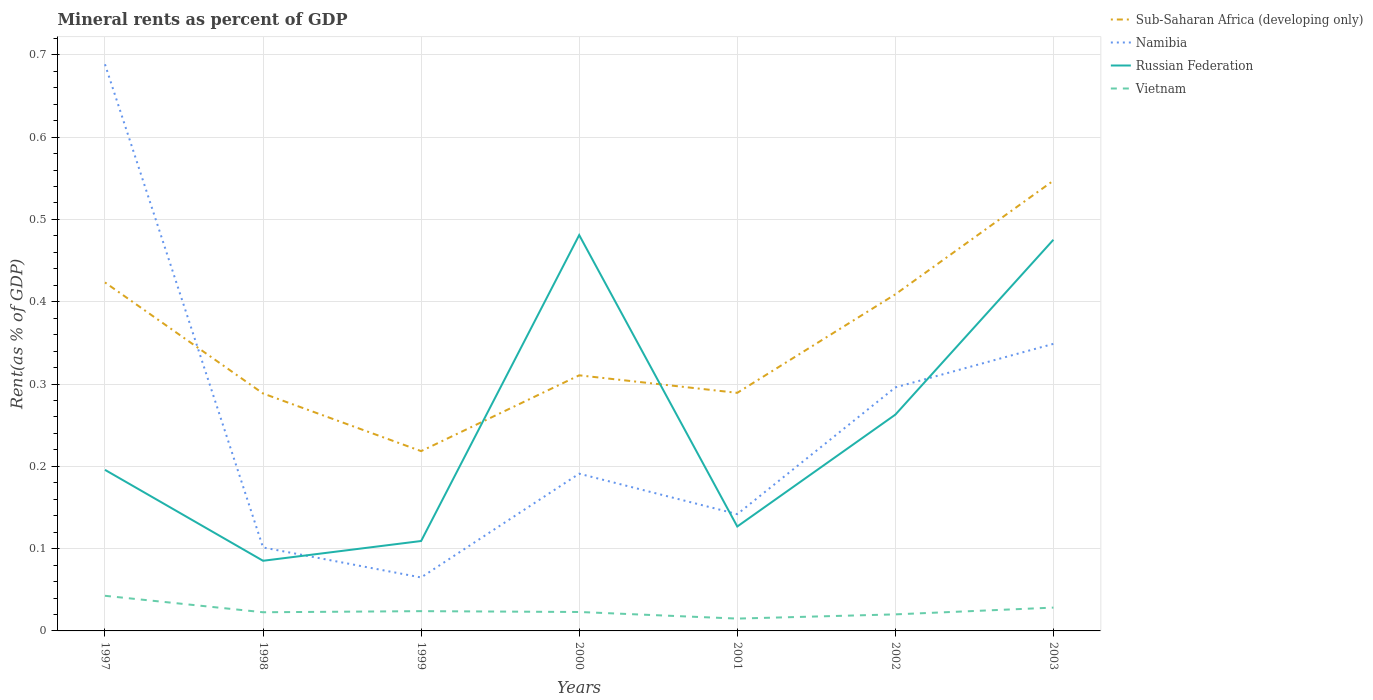How many different coloured lines are there?
Your answer should be compact. 4. Across all years, what is the maximum mineral rent in Sub-Saharan Africa (developing only)?
Ensure brevity in your answer.  0.22. What is the total mineral rent in Vietnam in the graph?
Provide a succinct answer. -0. What is the difference between the highest and the second highest mineral rent in Russian Federation?
Provide a short and direct response. 0.4. What is the difference between the highest and the lowest mineral rent in Vietnam?
Your answer should be compact. 2. How many lines are there?
Make the answer very short. 4. How many years are there in the graph?
Your response must be concise. 7. Does the graph contain any zero values?
Make the answer very short. No. How many legend labels are there?
Your answer should be very brief. 4. What is the title of the graph?
Provide a succinct answer. Mineral rents as percent of GDP. What is the label or title of the X-axis?
Your response must be concise. Years. What is the label or title of the Y-axis?
Offer a terse response. Rent(as % of GDP). What is the Rent(as % of GDP) of Sub-Saharan Africa (developing only) in 1997?
Offer a very short reply. 0.42. What is the Rent(as % of GDP) in Namibia in 1997?
Your answer should be very brief. 0.69. What is the Rent(as % of GDP) of Russian Federation in 1997?
Provide a short and direct response. 0.2. What is the Rent(as % of GDP) in Vietnam in 1997?
Your answer should be very brief. 0.04. What is the Rent(as % of GDP) in Sub-Saharan Africa (developing only) in 1998?
Your response must be concise. 0.29. What is the Rent(as % of GDP) of Namibia in 1998?
Give a very brief answer. 0.1. What is the Rent(as % of GDP) of Russian Federation in 1998?
Make the answer very short. 0.09. What is the Rent(as % of GDP) of Vietnam in 1998?
Ensure brevity in your answer.  0.02. What is the Rent(as % of GDP) of Sub-Saharan Africa (developing only) in 1999?
Ensure brevity in your answer.  0.22. What is the Rent(as % of GDP) of Namibia in 1999?
Offer a very short reply. 0.06. What is the Rent(as % of GDP) in Russian Federation in 1999?
Keep it short and to the point. 0.11. What is the Rent(as % of GDP) of Vietnam in 1999?
Provide a short and direct response. 0.02. What is the Rent(as % of GDP) in Sub-Saharan Africa (developing only) in 2000?
Your answer should be very brief. 0.31. What is the Rent(as % of GDP) in Namibia in 2000?
Your response must be concise. 0.19. What is the Rent(as % of GDP) of Russian Federation in 2000?
Your answer should be compact. 0.48. What is the Rent(as % of GDP) in Vietnam in 2000?
Your answer should be very brief. 0.02. What is the Rent(as % of GDP) of Sub-Saharan Africa (developing only) in 2001?
Ensure brevity in your answer.  0.29. What is the Rent(as % of GDP) in Namibia in 2001?
Offer a terse response. 0.14. What is the Rent(as % of GDP) of Russian Federation in 2001?
Provide a succinct answer. 0.13. What is the Rent(as % of GDP) in Vietnam in 2001?
Your answer should be compact. 0.01. What is the Rent(as % of GDP) in Sub-Saharan Africa (developing only) in 2002?
Ensure brevity in your answer.  0.41. What is the Rent(as % of GDP) of Namibia in 2002?
Provide a short and direct response. 0.3. What is the Rent(as % of GDP) in Russian Federation in 2002?
Ensure brevity in your answer.  0.26. What is the Rent(as % of GDP) in Vietnam in 2002?
Your answer should be compact. 0.02. What is the Rent(as % of GDP) in Sub-Saharan Africa (developing only) in 2003?
Your answer should be compact. 0.55. What is the Rent(as % of GDP) in Namibia in 2003?
Offer a terse response. 0.35. What is the Rent(as % of GDP) in Russian Federation in 2003?
Offer a terse response. 0.48. What is the Rent(as % of GDP) of Vietnam in 2003?
Your response must be concise. 0.03. Across all years, what is the maximum Rent(as % of GDP) of Sub-Saharan Africa (developing only)?
Provide a short and direct response. 0.55. Across all years, what is the maximum Rent(as % of GDP) in Namibia?
Provide a short and direct response. 0.69. Across all years, what is the maximum Rent(as % of GDP) of Russian Federation?
Offer a very short reply. 0.48. Across all years, what is the maximum Rent(as % of GDP) of Vietnam?
Keep it short and to the point. 0.04. Across all years, what is the minimum Rent(as % of GDP) in Sub-Saharan Africa (developing only)?
Make the answer very short. 0.22. Across all years, what is the minimum Rent(as % of GDP) of Namibia?
Your answer should be very brief. 0.06. Across all years, what is the minimum Rent(as % of GDP) in Russian Federation?
Offer a very short reply. 0.09. Across all years, what is the minimum Rent(as % of GDP) in Vietnam?
Provide a succinct answer. 0.01. What is the total Rent(as % of GDP) in Sub-Saharan Africa (developing only) in the graph?
Ensure brevity in your answer.  2.49. What is the total Rent(as % of GDP) in Namibia in the graph?
Provide a succinct answer. 1.83. What is the total Rent(as % of GDP) of Russian Federation in the graph?
Your answer should be very brief. 1.74. What is the total Rent(as % of GDP) in Vietnam in the graph?
Provide a succinct answer. 0.18. What is the difference between the Rent(as % of GDP) of Sub-Saharan Africa (developing only) in 1997 and that in 1998?
Provide a succinct answer. 0.13. What is the difference between the Rent(as % of GDP) of Namibia in 1997 and that in 1998?
Ensure brevity in your answer.  0.59. What is the difference between the Rent(as % of GDP) in Russian Federation in 1997 and that in 1998?
Offer a very short reply. 0.11. What is the difference between the Rent(as % of GDP) in Sub-Saharan Africa (developing only) in 1997 and that in 1999?
Give a very brief answer. 0.2. What is the difference between the Rent(as % of GDP) in Namibia in 1997 and that in 1999?
Offer a terse response. 0.62. What is the difference between the Rent(as % of GDP) in Russian Federation in 1997 and that in 1999?
Your response must be concise. 0.09. What is the difference between the Rent(as % of GDP) in Vietnam in 1997 and that in 1999?
Provide a short and direct response. 0.02. What is the difference between the Rent(as % of GDP) in Sub-Saharan Africa (developing only) in 1997 and that in 2000?
Give a very brief answer. 0.11. What is the difference between the Rent(as % of GDP) in Namibia in 1997 and that in 2000?
Offer a very short reply. 0.5. What is the difference between the Rent(as % of GDP) in Russian Federation in 1997 and that in 2000?
Your answer should be compact. -0.29. What is the difference between the Rent(as % of GDP) of Vietnam in 1997 and that in 2000?
Your answer should be very brief. 0.02. What is the difference between the Rent(as % of GDP) in Sub-Saharan Africa (developing only) in 1997 and that in 2001?
Your answer should be very brief. 0.13. What is the difference between the Rent(as % of GDP) of Namibia in 1997 and that in 2001?
Give a very brief answer. 0.55. What is the difference between the Rent(as % of GDP) of Russian Federation in 1997 and that in 2001?
Offer a very short reply. 0.07. What is the difference between the Rent(as % of GDP) of Vietnam in 1997 and that in 2001?
Keep it short and to the point. 0.03. What is the difference between the Rent(as % of GDP) in Sub-Saharan Africa (developing only) in 1997 and that in 2002?
Your answer should be compact. 0.01. What is the difference between the Rent(as % of GDP) of Namibia in 1997 and that in 2002?
Give a very brief answer. 0.39. What is the difference between the Rent(as % of GDP) of Russian Federation in 1997 and that in 2002?
Offer a terse response. -0.07. What is the difference between the Rent(as % of GDP) in Vietnam in 1997 and that in 2002?
Offer a terse response. 0.02. What is the difference between the Rent(as % of GDP) of Sub-Saharan Africa (developing only) in 1997 and that in 2003?
Keep it short and to the point. -0.12. What is the difference between the Rent(as % of GDP) in Namibia in 1997 and that in 2003?
Provide a short and direct response. 0.34. What is the difference between the Rent(as % of GDP) in Russian Federation in 1997 and that in 2003?
Ensure brevity in your answer.  -0.28. What is the difference between the Rent(as % of GDP) in Vietnam in 1997 and that in 2003?
Offer a terse response. 0.01. What is the difference between the Rent(as % of GDP) of Sub-Saharan Africa (developing only) in 1998 and that in 1999?
Make the answer very short. 0.07. What is the difference between the Rent(as % of GDP) of Namibia in 1998 and that in 1999?
Offer a terse response. 0.04. What is the difference between the Rent(as % of GDP) of Russian Federation in 1998 and that in 1999?
Your response must be concise. -0.02. What is the difference between the Rent(as % of GDP) in Vietnam in 1998 and that in 1999?
Your response must be concise. -0. What is the difference between the Rent(as % of GDP) in Sub-Saharan Africa (developing only) in 1998 and that in 2000?
Offer a very short reply. -0.02. What is the difference between the Rent(as % of GDP) in Namibia in 1998 and that in 2000?
Keep it short and to the point. -0.09. What is the difference between the Rent(as % of GDP) of Russian Federation in 1998 and that in 2000?
Your response must be concise. -0.4. What is the difference between the Rent(as % of GDP) in Vietnam in 1998 and that in 2000?
Provide a short and direct response. -0. What is the difference between the Rent(as % of GDP) in Sub-Saharan Africa (developing only) in 1998 and that in 2001?
Offer a very short reply. -0. What is the difference between the Rent(as % of GDP) of Namibia in 1998 and that in 2001?
Make the answer very short. -0.04. What is the difference between the Rent(as % of GDP) in Russian Federation in 1998 and that in 2001?
Provide a succinct answer. -0.04. What is the difference between the Rent(as % of GDP) in Vietnam in 1998 and that in 2001?
Provide a short and direct response. 0.01. What is the difference between the Rent(as % of GDP) of Sub-Saharan Africa (developing only) in 1998 and that in 2002?
Offer a terse response. -0.12. What is the difference between the Rent(as % of GDP) of Namibia in 1998 and that in 2002?
Provide a succinct answer. -0.19. What is the difference between the Rent(as % of GDP) in Russian Federation in 1998 and that in 2002?
Ensure brevity in your answer.  -0.18. What is the difference between the Rent(as % of GDP) in Vietnam in 1998 and that in 2002?
Offer a terse response. 0. What is the difference between the Rent(as % of GDP) in Sub-Saharan Africa (developing only) in 1998 and that in 2003?
Make the answer very short. -0.26. What is the difference between the Rent(as % of GDP) in Namibia in 1998 and that in 2003?
Ensure brevity in your answer.  -0.25. What is the difference between the Rent(as % of GDP) in Russian Federation in 1998 and that in 2003?
Offer a terse response. -0.39. What is the difference between the Rent(as % of GDP) of Vietnam in 1998 and that in 2003?
Give a very brief answer. -0.01. What is the difference between the Rent(as % of GDP) in Sub-Saharan Africa (developing only) in 1999 and that in 2000?
Keep it short and to the point. -0.09. What is the difference between the Rent(as % of GDP) in Namibia in 1999 and that in 2000?
Your answer should be compact. -0.13. What is the difference between the Rent(as % of GDP) in Russian Federation in 1999 and that in 2000?
Make the answer very short. -0.37. What is the difference between the Rent(as % of GDP) of Vietnam in 1999 and that in 2000?
Keep it short and to the point. 0. What is the difference between the Rent(as % of GDP) in Sub-Saharan Africa (developing only) in 1999 and that in 2001?
Your response must be concise. -0.07. What is the difference between the Rent(as % of GDP) of Namibia in 1999 and that in 2001?
Give a very brief answer. -0.08. What is the difference between the Rent(as % of GDP) in Russian Federation in 1999 and that in 2001?
Keep it short and to the point. -0.02. What is the difference between the Rent(as % of GDP) in Vietnam in 1999 and that in 2001?
Ensure brevity in your answer.  0.01. What is the difference between the Rent(as % of GDP) in Sub-Saharan Africa (developing only) in 1999 and that in 2002?
Your response must be concise. -0.19. What is the difference between the Rent(as % of GDP) in Namibia in 1999 and that in 2002?
Your answer should be very brief. -0.23. What is the difference between the Rent(as % of GDP) in Russian Federation in 1999 and that in 2002?
Your answer should be very brief. -0.15. What is the difference between the Rent(as % of GDP) in Vietnam in 1999 and that in 2002?
Offer a very short reply. 0. What is the difference between the Rent(as % of GDP) of Sub-Saharan Africa (developing only) in 1999 and that in 2003?
Your answer should be compact. -0.33. What is the difference between the Rent(as % of GDP) in Namibia in 1999 and that in 2003?
Provide a short and direct response. -0.28. What is the difference between the Rent(as % of GDP) in Russian Federation in 1999 and that in 2003?
Make the answer very short. -0.37. What is the difference between the Rent(as % of GDP) in Vietnam in 1999 and that in 2003?
Ensure brevity in your answer.  -0. What is the difference between the Rent(as % of GDP) of Sub-Saharan Africa (developing only) in 2000 and that in 2001?
Your response must be concise. 0.02. What is the difference between the Rent(as % of GDP) in Namibia in 2000 and that in 2001?
Your response must be concise. 0.05. What is the difference between the Rent(as % of GDP) of Russian Federation in 2000 and that in 2001?
Provide a succinct answer. 0.35. What is the difference between the Rent(as % of GDP) of Vietnam in 2000 and that in 2001?
Offer a very short reply. 0.01. What is the difference between the Rent(as % of GDP) in Sub-Saharan Africa (developing only) in 2000 and that in 2002?
Your answer should be very brief. -0.1. What is the difference between the Rent(as % of GDP) in Namibia in 2000 and that in 2002?
Give a very brief answer. -0.1. What is the difference between the Rent(as % of GDP) in Russian Federation in 2000 and that in 2002?
Provide a short and direct response. 0.22. What is the difference between the Rent(as % of GDP) of Vietnam in 2000 and that in 2002?
Your response must be concise. 0. What is the difference between the Rent(as % of GDP) of Sub-Saharan Africa (developing only) in 2000 and that in 2003?
Provide a succinct answer. -0.24. What is the difference between the Rent(as % of GDP) of Namibia in 2000 and that in 2003?
Provide a succinct answer. -0.16. What is the difference between the Rent(as % of GDP) in Russian Federation in 2000 and that in 2003?
Give a very brief answer. 0.01. What is the difference between the Rent(as % of GDP) of Vietnam in 2000 and that in 2003?
Keep it short and to the point. -0.01. What is the difference between the Rent(as % of GDP) of Sub-Saharan Africa (developing only) in 2001 and that in 2002?
Offer a very short reply. -0.12. What is the difference between the Rent(as % of GDP) in Namibia in 2001 and that in 2002?
Your answer should be very brief. -0.15. What is the difference between the Rent(as % of GDP) in Russian Federation in 2001 and that in 2002?
Your answer should be compact. -0.14. What is the difference between the Rent(as % of GDP) of Vietnam in 2001 and that in 2002?
Provide a short and direct response. -0.01. What is the difference between the Rent(as % of GDP) in Sub-Saharan Africa (developing only) in 2001 and that in 2003?
Offer a terse response. -0.26. What is the difference between the Rent(as % of GDP) of Namibia in 2001 and that in 2003?
Keep it short and to the point. -0.21. What is the difference between the Rent(as % of GDP) in Russian Federation in 2001 and that in 2003?
Your response must be concise. -0.35. What is the difference between the Rent(as % of GDP) in Vietnam in 2001 and that in 2003?
Give a very brief answer. -0.01. What is the difference between the Rent(as % of GDP) in Sub-Saharan Africa (developing only) in 2002 and that in 2003?
Provide a succinct answer. -0.14. What is the difference between the Rent(as % of GDP) in Namibia in 2002 and that in 2003?
Your answer should be very brief. -0.05. What is the difference between the Rent(as % of GDP) in Russian Federation in 2002 and that in 2003?
Your response must be concise. -0.21. What is the difference between the Rent(as % of GDP) of Vietnam in 2002 and that in 2003?
Keep it short and to the point. -0.01. What is the difference between the Rent(as % of GDP) in Sub-Saharan Africa (developing only) in 1997 and the Rent(as % of GDP) in Namibia in 1998?
Offer a very short reply. 0.32. What is the difference between the Rent(as % of GDP) of Sub-Saharan Africa (developing only) in 1997 and the Rent(as % of GDP) of Russian Federation in 1998?
Give a very brief answer. 0.34. What is the difference between the Rent(as % of GDP) in Sub-Saharan Africa (developing only) in 1997 and the Rent(as % of GDP) in Vietnam in 1998?
Keep it short and to the point. 0.4. What is the difference between the Rent(as % of GDP) of Namibia in 1997 and the Rent(as % of GDP) of Russian Federation in 1998?
Give a very brief answer. 0.6. What is the difference between the Rent(as % of GDP) of Namibia in 1997 and the Rent(as % of GDP) of Vietnam in 1998?
Provide a succinct answer. 0.67. What is the difference between the Rent(as % of GDP) in Russian Federation in 1997 and the Rent(as % of GDP) in Vietnam in 1998?
Your answer should be very brief. 0.17. What is the difference between the Rent(as % of GDP) of Sub-Saharan Africa (developing only) in 1997 and the Rent(as % of GDP) of Namibia in 1999?
Your answer should be very brief. 0.36. What is the difference between the Rent(as % of GDP) of Sub-Saharan Africa (developing only) in 1997 and the Rent(as % of GDP) of Russian Federation in 1999?
Your answer should be compact. 0.31. What is the difference between the Rent(as % of GDP) of Sub-Saharan Africa (developing only) in 1997 and the Rent(as % of GDP) of Vietnam in 1999?
Your response must be concise. 0.4. What is the difference between the Rent(as % of GDP) in Namibia in 1997 and the Rent(as % of GDP) in Russian Federation in 1999?
Your answer should be very brief. 0.58. What is the difference between the Rent(as % of GDP) of Namibia in 1997 and the Rent(as % of GDP) of Vietnam in 1999?
Offer a very short reply. 0.66. What is the difference between the Rent(as % of GDP) of Russian Federation in 1997 and the Rent(as % of GDP) of Vietnam in 1999?
Provide a short and direct response. 0.17. What is the difference between the Rent(as % of GDP) of Sub-Saharan Africa (developing only) in 1997 and the Rent(as % of GDP) of Namibia in 2000?
Your answer should be compact. 0.23. What is the difference between the Rent(as % of GDP) of Sub-Saharan Africa (developing only) in 1997 and the Rent(as % of GDP) of Russian Federation in 2000?
Provide a succinct answer. -0.06. What is the difference between the Rent(as % of GDP) of Sub-Saharan Africa (developing only) in 1997 and the Rent(as % of GDP) of Vietnam in 2000?
Provide a succinct answer. 0.4. What is the difference between the Rent(as % of GDP) of Namibia in 1997 and the Rent(as % of GDP) of Russian Federation in 2000?
Keep it short and to the point. 0.21. What is the difference between the Rent(as % of GDP) in Namibia in 1997 and the Rent(as % of GDP) in Vietnam in 2000?
Your response must be concise. 0.67. What is the difference between the Rent(as % of GDP) in Russian Federation in 1997 and the Rent(as % of GDP) in Vietnam in 2000?
Your answer should be very brief. 0.17. What is the difference between the Rent(as % of GDP) of Sub-Saharan Africa (developing only) in 1997 and the Rent(as % of GDP) of Namibia in 2001?
Your response must be concise. 0.28. What is the difference between the Rent(as % of GDP) in Sub-Saharan Africa (developing only) in 1997 and the Rent(as % of GDP) in Russian Federation in 2001?
Your answer should be compact. 0.3. What is the difference between the Rent(as % of GDP) in Sub-Saharan Africa (developing only) in 1997 and the Rent(as % of GDP) in Vietnam in 2001?
Make the answer very short. 0.41. What is the difference between the Rent(as % of GDP) of Namibia in 1997 and the Rent(as % of GDP) of Russian Federation in 2001?
Offer a terse response. 0.56. What is the difference between the Rent(as % of GDP) in Namibia in 1997 and the Rent(as % of GDP) in Vietnam in 2001?
Offer a very short reply. 0.67. What is the difference between the Rent(as % of GDP) of Russian Federation in 1997 and the Rent(as % of GDP) of Vietnam in 2001?
Make the answer very short. 0.18. What is the difference between the Rent(as % of GDP) in Sub-Saharan Africa (developing only) in 1997 and the Rent(as % of GDP) in Namibia in 2002?
Your answer should be very brief. 0.13. What is the difference between the Rent(as % of GDP) in Sub-Saharan Africa (developing only) in 1997 and the Rent(as % of GDP) in Russian Federation in 2002?
Offer a terse response. 0.16. What is the difference between the Rent(as % of GDP) of Sub-Saharan Africa (developing only) in 1997 and the Rent(as % of GDP) of Vietnam in 2002?
Your answer should be compact. 0.4. What is the difference between the Rent(as % of GDP) of Namibia in 1997 and the Rent(as % of GDP) of Russian Federation in 2002?
Your response must be concise. 0.43. What is the difference between the Rent(as % of GDP) in Namibia in 1997 and the Rent(as % of GDP) in Vietnam in 2002?
Provide a succinct answer. 0.67. What is the difference between the Rent(as % of GDP) in Russian Federation in 1997 and the Rent(as % of GDP) in Vietnam in 2002?
Keep it short and to the point. 0.18. What is the difference between the Rent(as % of GDP) of Sub-Saharan Africa (developing only) in 1997 and the Rent(as % of GDP) of Namibia in 2003?
Keep it short and to the point. 0.07. What is the difference between the Rent(as % of GDP) in Sub-Saharan Africa (developing only) in 1997 and the Rent(as % of GDP) in Russian Federation in 2003?
Give a very brief answer. -0.05. What is the difference between the Rent(as % of GDP) of Sub-Saharan Africa (developing only) in 1997 and the Rent(as % of GDP) of Vietnam in 2003?
Keep it short and to the point. 0.4. What is the difference between the Rent(as % of GDP) in Namibia in 1997 and the Rent(as % of GDP) in Russian Federation in 2003?
Your answer should be very brief. 0.21. What is the difference between the Rent(as % of GDP) of Namibia in 1997 and the Rent(as % of GDP) of Vietnam in 2003?
Ensure brevity in your answer.  0.66. What is the difference between the Rent(as % of GDP) in Russian Federation in 1997 and the Rent(as % of GDP) in Vietnam in 2003?
Offer a terse response. 0.17. What is the difference between the Rent(as % of GDP) in Sub-Saharan Africa (developing only) in 1998 and the Rent(as % of GDP) in Namibia in 1999?
Provide a succinct answer. 0.22. What is the difference between the Rent(as % of GDP) of Sub-Saharan Africa (developing only) in 1998 and the Rent(as % of GDP) of Russian Federation in 1999?
Keep it short and to the point. 0.18. What is the difference between the Rent(as % of GDP) in Sub-Saharan Africa (developing only) in 1998 and the Rent(as % of GDP) in Vietnam in 1999?
Offer a very short reply. 0.26. What is the difference between the Rent(as % of GDP) of Namibia in 1998 and the Rent(as % of GDP) of Russian Federation in 1999?
Give a very brief answer. -0.01. What is the difference between the Rent(as % of GDP) in Namibia in 1998 and the Rent(as % of GDP) in Vietnam in 1999?
Your response must be concise. 0.08. What is the difference between the Rent(as % of GDP) in Russian Federation in 1998 and the Rent(as % of GDP) in Vietnam in 1999?
Provide a succinct answer. 0.06. What is the difference between the Rent(as % of GDP) in Sub-Saharan Africa (developing only) in 1998 and the Rent(as % of GDP) in Namibia in 2000?
Your response must be concise. 0.1. What is the difference between the Rent(as % of GDP) in Sub-Saharan Africa (developing only) in 1998 and the Rent(as % of GDP) in Russian Federation in 2000?
Offer a terse response. -0.19. What is the difference between the Rent(as % of GDP) of Sub-Saharan Africa (developing only) in 1998 and the Rent(as % of GDP) of Vietnam in 2000?
Your answer should be very brief. 0.27. What is the difference between the Rent(as % of GDP) in Namibia in 1998 and the Rent(as % of GDP) in Russian Federation in 2000?
Your answer should be very brief. -0.38. What is the difference between the Rent(as % of GDP) in Namibia in 1998 and the Rent(as % of GDP) in Vietnam in 2000?
Make the answer very short. 0.08. What is the difference between the Rent(as % of GDP) in Russian Federation in 1998 and the Rent(as % of GDP) in Vietnam in 2000?
Keep it short and to the point. 0.06. What is the difference between the Rent(as % of GDP) of Sub-Saharan Africa (developing only) in 1998 and the Rent(as % of GDP) of Namibia in 2001?
Ensure brevity in your answer.  0.15. What is the difference between the Rent(as % of GDP) in Sub-Saharan Africa (developing only) in 1998 and the Rent(as % of GDP) in Russian Federation in 2001?
Keep it short and to the point. 0.16. What is the difference between the Rent(as % of GDP) in Sub-Saharan Africa (developing only) in 1998 and the Rent(as % of GDP) in Vietnam in 2001?
Ensure brevity in your answer.  0.27. What is the difference between the Rent(as % of GDP) in Namibia in 1998 and the Rent(as % of GDP) in Russian Federation in 2001?
Provide a succinct answer. -0.03. What is the difference between the Rent(as % of GDP) in Namibia in 1998 and the Rent(as % of GDP) in Vietnam in 2001?
Give a very brief answer. 0.09. What is the difference between the Rent(as % of GDP) in Russian Federation in 1998 and the Rent(as % of GDP) in Vietnam in 2001?
Give a very brief answer. 0.07. What is the difference between the Rent(as % of GDP) of Sub-Saharan Africa (developing only) in 1998 and the Rent(as % of GDP) of Namibia in 2002?
Your answer should be compact. -0.01. What is the difference between the Rent(as % of GDP) in Sub-Saharan Africa (developing only) in 1998 and the Rent(as % of GDP) in Russian Federation in 2002?
Provide a succinct answer. 0.03. What is the difference between the Rent(as % of GDP) of Sub-Saharan Africa (developing only) in 1998 and the Rent(as % of GDP) of Vietnam in 2002?
Your answer should be very brief. 0.27. What is the difference between the Rent(as % of GDP) in Namibia in 1998 and the Rent(as % of GDP) in Russian Federation in 2002?
Offer a terse response. -0.16. What is the difference between the Rent(as % of GDP) in Namibia in 1998 and the Rent(as % of GDP) in Vietnam in 2002?
Provide a succinct answer. 0.08. What is the difference between the Rent(as % of GDP) in Russian Federation in 1998 and the Rent(as % of GDP) in Vietnam in 2002?
Provide a succinct answer. 0.07. What is the difference between the Rent(as % of GDP) in Sub-Saharan Africa (developing only) in 1998 and the Rent(as % of GDP) in Namibia in 2003?
Keep it short and to the point. -0.06. What is the difference between the Rent(as % of GDP) of Sub-Saharan Africa (developing only) in 1998 and the Rent(as % of GDP) of Russian Federation in 2003?
Make the answer very short. -0.19. What is the difference between the Rent(as % of GDP) of Sub-Saharan Africa (developing only) in 1998 and the Rent(as % of GDP) of Vietnam in 2003?
Offer a very short reply. 0.26. What is the difference between the Rent(as % of GDP) of Namibia in 1998 and the Rent(as % of GDP) of Russian Federation in 2003?
Keep it short and to the point. -0.37. What is the difference between the Rent(as % of GDP) in Namibia in 1998 and the Rent(as % of GDP) in Vietnam in 2003?
Offer a terse response. 0.07. What is the difference between the Rent(as % of GDP) of Russian Federation in 1998 and the Rent(as % of GDP) of Vietnam in 2003?
Offer a very short reply. 0.06. What is the difference between the Rent(as % of GDP) of Sub-Saharan Africa (developing only) in 1999 and the Rent(as % of GDP) of Namibia in 2000?
Give a very brief answer. 0.03. What is the difference between the Rent(as % of GDP) of Sub-Saharan Africa (developing only) in 1999 and the Rent(as % of GDP) of Russian Federation in 2000?
Give a very brief answer. -0.26. What is the difference between the Rent(as % of GDP) of Sub-Saharan Africa (developing only) in 1999 and the Rent(as % of GDP) of Vietnam in 2000?
Make the answer very short. 0.2. What is the difference between the Rent(as % of GDP) in Namibia in 1999 and the Rent(as % of GDP) in Russian Federation in 2000?
Provide a short and direct response. -0.42. What is the difference between the Rent(as % of GDP) of Namibia in 1999 and the Rent(as % of GDP) of Vietnam in 2000?
Provide a short and direct response. 0.04. What is the difference between the Rent(as % of GDP) in Russian Federation in 1999 and the Rent(as % of GDP) in Vietnam in 2000?
Keep it short and to the point. 0.09. What is the difference between the Rent(as % of GDP) of Sub-Saharan Africa (developing only) in 1999 and the Rent(as % of GDP) of Namibia in 2001?
Your answer should be very brief. 0.08. What is the difference between the Rent(as % of GDP) of Sub-Saharan Africa (developing only) in 1999 and the Rent(as % of GDP) of Russian Federation in 2001?
Make the answer very short. 0.09. What is the difference between the Rent(as % of GDP) of Sub-Saharan Africa (developing only) in 1999 and the Rent(as % of GDP) of Vietnam in 2001?
Provide a short and direct response. 0.2. What is the difference between the Rent(as % of GDP) of Namibia in 1999 and the Rent(as % of GDP) of Russian Federation in 2001?
Your response must be concise. -0.06. What is the difference between the Rent(as % of GDP) of Russian Federation in 1999 and the Rent(as % of GDP) of Vietnam in 2001?
Provide a short and direct response. 0.09. What is the difference between the Rent(as % of GDP) in Sub-Saharan Africa (developing only) in 1999 and the Rent(as % of GDP) in Namibia in 2002?
Give a very brief answer. -0.08. What is the difference between the Rent(as % of GDP) in Sub-Saharan Africa (developing only) in 1999 and the Rent(as % of GDP) in Russian Federation in 2002?
Offer a very short reply. -0.04. What is the difference between the Rent(as % of GDP) of Sub-Saharan Africa (developing only) in 1999 and the Rent(as % of GDP) of Vietnam in 2002?
Provide a succinct answer. 0.2. What is the difference between the Rent(as % of GDP) of Namibia in 1999 and the Rent(as % of GDP) of Russian Federation in 2002?
Keep it short and to the point. -0.2. What is the difference between the Rent(as % of GDP) in Namibia in 1999 and the Rent(as % of GDP) in Vietnam in 2002?
Keep it short and to the point. 0.04. What is the difference between the Rent(as % of GDP) of Russian Federation in 1999 and the Rent(as % of GDP) of Vietnam in 2002?
Provide a short and direct response. 0.09. What is the difference between the Rent(as % of GDP) of Sub-Saharan Africa (developing only) in 1999 and the Rent(as % of GDP) of Namibia in 2003?
Offer a very short reply. -0.13. What is the difference between the Rent(as % of GDP) in Sub-Saharan Africa (developing only) in 1999 and the Rent(as % of GDP) in Russian Federation in 2003?
Provide a succinct answer. -0.26. What is the difference between the Rent(as % of GDP) of Sub-Saharan Africa (developing only) in 1999 and the Rent(as % of GDP) of Vietnam in 2003?
Make the answer very short. 0.19. What is the difference between the Rent(as % of GDP) of Namibia in 1999 and the Rent(as % of GDP) of Russian Federation in 2003?
Give a very brief answer. -0.41. What is the difference between the Rent(as % of GDP) in Namibia in 1999 and the Rent(as % of GDP) in Vietnam in 2003?
Make the answer very short. 0.04. What is the difference between the Rent(as % of GDP) in Russian Federation in 1999 and the Rent(as % of GDP) in Vietnam in 2003?
Make the answer very short. 0.08. What is the difference between the Rent(as % of GDP) of Sub-Saharan Africa (developing only) in 2000 and the Rent(as % of GDP) of Namibia in 2001?
Provide a short and direct response. 0.17. What is the difference between the Rent(as % of GDP) in Sub-Saharan Africa (developing only) in 2000 and the Rent(as % of GDP) in Russian Federation in 2001?
Offer a very short reply. 0.18. What is the difference between the Rent(as % of GDP) of Sub-Saharan Africa (developing only) in 2000 and the Rent(as % of GDP) of Vietnam in 2001?
Your response must be concise. 0.3. What is the difference between the Rent(as % of GDP) of Namibia in 2000 and the Rent(as % of GDP) of Russian Federation in 2001?
Your answer should be compact. 0.06. What is the difference between the Rent(as % of GDP) of Namibia in 2000 and the Rent(as % of GDP) of Vietnam in 2001?
Your answer should be very brief. 0.18. What is the difference between the Rent(as % of GDP) of Russian Federation in 2000 and the Rent(as % of GDP) of Vietnam in 2001?
Ensure brevity in your answer.  0.47. What is the difference between the Rent(as % of GDP) in Sub-Saharan Africa (developing only) in 2000 and the Rent(as % of GDP) in Namibia in 2002?
Ensure brevity in your answer.  0.01. What is the difference between the Rent(as % of GDP) in Sub-Saharan Africa (developing only) in 2000 and the Rent(as % of GDP) in Russian Federation in 2002?
Your answer should be compact. 0.05. What is the difference between the Rent(as % of GDP) of Sub-Saharan Africa (developing only) in 2000 and the Rent(as % of GDP) of Vietnam in 2002?
Provide a succinct answer. 0.29. What is the difference between the Rent(as % of GDP) of Namibia in 2000 and the Rent(as % of GDP) of Russian Federation in 2002?
Give a very brief answer. -0.07. What is the difference between the Rent(as % of GDP) of Namibia in 2000 and the Rent(as % of GDP) of Vietnam in 2002?
Your response must be concise. 0.17. What is the difference between the Rent(as % of GDP) in Russian Federation in 2000 and the Rent(as % of GDP) in Vietnam in 2002?
Offer a very short reply. 0.46. What is the difference between the Rent(as % of GDP) of Sub-Saharan Africa (developing only) in 2000 and the Rent(as % of GDP) of Namibia in 2003?
Your answer should be very brief. -0.04. What is the difference between the Rent(as % of GDP) in Sub-Saharan Africa (developing only) in 2000 and the Rent(as % of GDP) in Russian Federation in 2003?
Your answer should be compact. -0.16. What is the difference between the Rent(as % of GDP) in Sub-Saharan Africa (developing only) in 2000 and the Rent(as % of GDP) in Vietnam in 2003?
Offer a terse response. 0.28. What is the difference between the Rent(as % of GDP) in Namibia in 2000 and the Rent(as % of GDP) in Russian Federation in 2003?
Provide a short and direct response. -0.28. What is the difference between the Rent(as % of GDP) in Namibia in 2000 and the Rent(as % of GDP) in Vietnam in 2003?
Your answer should be compact. 0.16. What is the difference between the Rent(as % of GDP) of Russian Federation in 2000 and the Rent(as % of GDP) of Vietnam in 2003?
Your answer should be very brief. 0.45. What is the difference between the Rent(as % of GDP) in Sub-Saharan Africa (developing only) in 2001 and the Rent(as % of GDP) in Namibia in 2002?
Your response must be concise. -0.01. What is the difference between the Rent(as % of GDP) of Sub-Saharan Africa (developing only) in 2001 and the Rent(as % of GDP) of Russian Federation in 2002?
Provide a short and direct response. 0.03. What is the difference between the Rent(as % of GDP) in Sub-Saharan Africa (developing only) in 2001 and the Rent(as % of GDP) in Vietnam in 2002?
Provide a succinct answer. 0.27. What is the difference between the Rent(as % of GDP) in Namibia in 2001 and the Rent(as % of GDP) in Russian Federation in 2002?
Ensure brevity in your answer.  -0.12. What is the difference between the Rent(as % of GDP) in Namibia in 2001 and the Rent(as % of GDP) in Vietnam in 2002?
Your response must be concise. 0.12. What is the difference between the Rent(as % of GDP) in Russian Federation in 2001 and the Rent(as % of GDP) in Vietnam in 2002?
Offer a very short reply. 0.11. What is the difference between the Rent(as % of GDP) in Sub-Saharan Africa (developing only) in 2001 and the Rent(as % of GDP) in Namibia in 2003?
Provide a short and direct response. -0.06. What is the difference between the Rent(as % of GDP) of Sub-Saharan Africa (developing only) in 2001 and the Rent(as % of GDP) of Russian Federation in 2003?
Give a very brief answer. -0.19. What is the difference between the Rent(as % of GDP) of Sub-Saharan Africa (developing only) in 2001 and the Rent(as % of GDP) of Vietnam in 2003?
Offer a terse response. 0.26. What is the difference between the Rent(as % of GDP) in Namibia in 2001 and the Rent(as % of GDP) in Russian Federation in 2003?
Offer a terse response. -0.33. What is the difference between the Rent(as % of GDP) of Namibia in 2001 and the Rent(as % of GDP) of Vietnam in 2003?
Your answer should be compact. 0.11. What is the difference between the Rent(as % of GDP) in Russian Federation in 2001 and the Rent(as % of GDP) in Vietnam in 2003?
Your answer should be compact. 0.1. What is the difference between the Rent(as % of GDP) of Sub-Saharan Africa (developing only) in 2002 and the Rent(as % of GDP) of Namibia in 2003?
Your response must be concise. 0.06. What is the difference between the Rent(as % of GDP) in Sub-Saharan Africa (developing only) in 2002 and the Rent(as % of GDP) in Russian Federation in 2003?
Offer a terse response. -0.07. What is the difference between the Rent(as % of GDP) in Sub-Saharan Africa (developing only) in 2002 and the Rent(as % of GDP) in Vietnam in 2003?
Give a very brief answer. 0.38. What is the difference between the Rent(as % of GDP) in Namibia in 2002 and the Rent(as % of GDP) in Russian Federation in 2003?
Your answer should be compact. -0.18. What is the difference between the Rent(as % of GDP) of Namibia in 2002 and the Rent(as % of GDP) of Vietnam in 2003?
Make the answer very short. 0.27. What is the difference between the Rent(as % of GDP) of Russian Federation in 2002 and the Rent(as % of GDP) of Vietnam in 2003?
Your response must be concise. 0.23. What is the average Rent(as % of GDP) of Sub-Saharan Africa (developing only) per year?
Your answer should be very brief. 0.36. What is the average Rent(as % of GDP) in Namibia per year?
Your answer should be very brief. 0.26. What is the average Rent(as % of GDP) of Russian Federation per year?
Your answer should be very brief. 0.25. What is the average Rent(as % of GDP) of Vietnam per year?
Ensure brevity in your answer.  0.03. In the year 1997, what is the difference between the Rent(as % of GDP) of Sub-Saharan Africa (developing only) and Rent(as % of GDP) of Namibia?
Keep it short and to the point. -0.27. In the year 1997, what is the difference between the Rent(as % of GDP) of Sub-Saharan Africa (developing only) and Rent(as % of GDP) of Russian Federation?
Provide a short and direct response. 0.23. In the year 1997, what is the difference between the Rent(as % of GDP) in Sub-Saharan Africa (developing only) and Rent(as % of GDP) in Vietnam?
Ensure brevity in your answer.  0.38. In the year 1997, what is the difference between the Rent(as % of GDP) of Namibia and Rent(as % of GDP) of Russian Federation?
Provide a short and direct response. 0.49. In the year 1997, what is the difference between the Rent(as % of GDP) of Namibia and Rent(as % of GDP) of Vietnam?
Offer a very short reply. 0.65. In the year 1997, what is the difference between the Rent(as % of GDP) of Russian Federation and Rent(as % of GDP) of Vietnam?
Make the answer very short. 0.15. In the year 1998, what is the difference between the Rent(as % of GDP) of Sub-Saharan Africa (developing only) and Rent(as % of GDP) of Namibia?
Ensure brevity in your answer.  0.19. In the year 1998, what is the difference between the Rent(as % of GDP) of Sub-Saharan Africa (developing only) and Rent(as % of GDP) of Russian Federation?
Offer a very short reply. 0.2. In the year 1998, what is the difference between the Rent(as % of GDP) of Sub-Saharan Africa (developing only) and Rent(as % of GDP) of Vietnam?
Provide a succinct answer. 0.27. In the year 1998, what is the difference between the Rent(as % of GDP) in Namibia and Rent(as % of GDP) in Russian Federation?
Offer a terse response. 0.02. In the year 1998, what is the difference between the Rent(as % of GDP) of Namibia and Rent(as % of GDP) of Vietnam?
Offer a terse response. 0.08. In the year 1998, what is the difference between the Rent(as % of GDP) of Russian Federation and Rent(as % of GDP) of Vietnam?
Keep it short and to the point. 0.06. In the year 1999, what is the difference between the Rent(as % of GDP) of Sub-Saharan Africa (developing only) and Rent(as % of GDP) of Namibia?
Offer a very short reply. 0.15. In the year 1999, what is the difference between the Rent(as % of GDP) in Sub-Saharan Africa (developing only) and Rent(as % of GDP) in Russian Federation?
Your answer should be compact. 0.11. In the year 1999, what is the difference between the Rent(as % of GDP) of Sub-Saharan Africa (developing only) and Rent(as % of GDP) of Vietnam?
Keep it short and to the point. 0.19. In the year 1999, what is the difference between the Rent(as % of GDP) of Namibia and Rent(as % of GDP) of Russian Federation?
Offer a very short reply. -0.04. In the year 1999, what is the difference between the Rent(as % of GDP) in Namibia and Rent(as % of GDP) in Vietnam?
Keep it short and to the point. 0.04. In the year 1999, what is the difference between the Rent(as % of GDP) in Russian Federation and Rent(as % of GDP) in Vietnam?
Give a very brief answer. 0.09. In the year 2000, what is the difference between the Rent(as % of GDP) of Sub-Saharan Africa (developing only) and Rent(as % of GDP) of Namibia?
Your answer should be very brief. 0.12. In the year 2000, what is the difference between the Rent(as % of GDP) of Sub-Saharan Africa (developing only) and Rent(as % of GDP) of Russian Federation?
Provide a short and direct response. -0.17. In the year 2000, what is the difference between the Rent(as % of GDP) of Sub-Saharan Africa (developing only) and Rent(as % of GDP) of Vietnam?
Offer a terse response. 0.29. In the year 2000, what is the difference between the Rent(as % of GDP) of Namibia and Rent(as % of GDP) of Russian Federation?
Give a very brief answer. -0.29. In the year 2000, what is the difference between the Rent(as % of GDP) of Namibia and Rent(as % of GDP) of Vietnam?
Provide a succinct answer. 0.17. In the year 2000, what is the difference between the Rent(as % of GDP) in Russian Federation and Rent(as % of GDP) in Vietnam?
Offer a terse response. 0.46. In the year 2001, what is the difference between the Rent(as % of GDP) in Sub-Saharan Africa (developing only) and Rent(as % of GDP) in Namibia?
Your answer should be very brief. 0.15. In the year 2001, what is the difference between the Rent(as % of GDP) of Sub-Saharan Africa (developing only) and Rent(as % of GDP) of Russian Federation?
Provide a short and direct response. 0.16. In the year 2001, what is the difference between the Rent(as % of GDP) of Sub-Saharan Africa (developing only) and Rent(as % of GDP) of Vietnam?
Provide a short and direct response. 0.27. In the year 2001, what is the difference between the Rent(as % of GDP) in Namibia and Rent(as % of GDP) in Russian Federation?
Your response must be concise. 0.01. In the year 2001, what is the difference between the Rent(as % of GDP) of Namibia and Rent(as % of GDP) of Vietnam?
Offer a very short reply. 0.13. In the year 2001, what is the difference between the Rent(as % of GDP) of Russian Federation and Rent(as % of GDP) of Vietnam?
Your response must be concise. 0.11. In the year 2002, what is the difference between the Rent(as % of GDP) in Sub-Saharan Africa (developing only) and Rent(as % of GDP) in Namibia?
Your answer should be very brief. 0.11. In the year 2002, what is the difference between the Rent(as % of GDP) of Sub-Saharan Africa (developing only) and Rent(as % of GDP) of Russian Federation?
Give a very brief answer. 0.15. In the year 2002, what is the difference between the Rent(as % of GDP) in Sub-Saharan Africa (developing only) and Rent(as % of GDP) in Vietnam?
Provide a succinct answer. 0.39. In the year 2002, what is the difference between the Rent(as % of GDP) of Namibia and Rent(as % of GDP) of Russian Federation?
Your response must be concise. 0.03. In the year 2002, what is the difference between the Rent(as % of GDP) in Namibia and Rent(as % of GDP) in Vietnam?
Offer a very short reply. 0.28. In the year 2002, what is the difference between the Rent(as % of GDP) of Russian Federation and Rent(as % of GDP) of Vietnam?
Provide a short and direct response. 0.24. In the year 2003, what is the difference between the Rent(as % of GDP) of Sub-Saharan Africa (developing only) and Rent(as % of GDP) of Namibia?
Your answer should be compact. 0.2. In the year 2003, what is the difference between the Rent(as % of GDP) in Sub-Saharan Africa (developing only) and Rent(as % of GDP) in Russian Federation?
Offer a terse response. 0.07. In the year 2003, what is the difference between the Rent(as % of GDP) of Sub-Saharan Africa (developing only) and Rent(as % of GDP) of Vietnam?
Provide a succinct answer. 0.52. In the year 2003, what is the difference between the Rent(as % of GDP) in Namibia and Rent(as % of GDP) in Russian Federation?
Your answer should be very brief. -0.13. In the year 2003, what is the difference between the Rent(as % of GDP) in Namibia and Rent(as % of GDP) in Vietnam?
Ensure brevity in your answer.  0.32. In the year 2003, what is the difference between the Rent(as % of GDP) in Russian Federation and Rent(as % of GDP) in Vietnam?
Provide a succinct answer. 0.45. What is the ratio of the Rent(as % of GDP) in Sub-Saharan Africa (developing only) in 1997 to that in 1998?
Your answer should be very brief. 1.47. What is the ratio of the Rent(as % of GDP) of Namibia in 1997 to that in 1998?
Your answer should be very brief. 6.79. What is the ratio of the Rent(as % of GDP) of Russian Federation in 1997 to that in 1998?
Offer a very short reply. 2.3. What is the ratio of the Rent(as % of GDP) of Vietnam in 1997 to that in 1998?
Make the answer very short. 1.88. What is the ratio of the Rent(as % of GDP) of Sub-Saharan Africa (developing only) in 1997 to that in 1999?
Your answer should be very brief. 1.94. What is the ratio of the Rent(as % of GDP) in Namibia in 1997 to that in 1999?
Your answer should be compact. 10.6. What is the ratio of the Rent(as % of GDP) in Russian Federation in 1997 to that in 1999?
Ensure brevity in your answer.  1.79. What is the ratio of the Rent(as % of GDP) of Vietnam in 1997 to that in 1999?
Give a very brief answer. 1.78. What is the ratio of the Rent(as % of GDP) of Sub-Saharan Africa (developing only) in 1997 to that in 2000?
Make the answer very short. 1.36. What is the ratio of the Rent(as % of GDP) of Namibia in 1997 to that in 2000?
Your answer should be compact. 3.6. What is the ratio of the Rent(as % of GDP) of Russian Federation in 1997 to that in 2000?
Offer a terse response. 0.41. What is the ratio of the Rent(as % of GDP) in Vietnam in 1997 to that in 2000?
Keep it short and to the point. 1.86. What is the ratio of the Rent(as % of GDP) of Sub-Saharan Africa (developing only) in 1997 to that in 2001?
Ensure brevity in your answer.  1.46. What is the ratio of the Rent(as % of GDP) in Namibia in 1997 to that in 2001?
Your answer should be very brief. 4.85. What is the ratio of the Rent(as % of GDP) in Russian Federation in 1997 to that in 2001?
Your response must be concise. 1.54. What is the ratio of the Rent(as % of GDP) of Vietnam in 1997 to that in 2001?
Provide a succinct answer. 2.85. What is the ratio of the Rent(as % of GDP) in Sub-Saharan Africa (developing only) in 1997 to that in 2002?
Provide a succinct answer. 1.04. What is the ratio of the Rent(as % of GDP) in Namibia in 1997 to that in 2002?
Your answer should be very brief. 2.33. What is the ratio of the Rent(as % of GDP) of Russian Federation in 1997 to that in 2002?
Offer a terse response. 0.74. What is the ratio of the Rent(as % of GDP) of Vietnam in 1997 to that in 2002?
Your answer should be compact. 2.12. What is the ratio of the Rent(as % of GDP) in Sub-Saharan Africa (developing only) in 1997 to that in 2003?
Keep it short and to the point. 0.77. What is the ratio of the Rent(as % of GDP) in Namibia in 1997 to that in 2003?
Give a very brief answer. 1.97. What is the ratio of the Rent(as % of GDP) of Russian Federation in 1997 to that in 2003?
Offer a very short reply. 0.41. What is the ratio of the Rent(as % of GDP) in Vietnam in 1997 to that in 2003?
Ensure brevity in your answer.  1.51. What is the ratio of the Rent(as % of GDP) in Sub-Saharan Africa (developing only) in 1998 to that in 1999?
Keep it short and to the point. 1.32. What is the ratio of the Rent(as % of GDP) of Namibia in 1998 to that in 1999?
Give a very brief answer. 1.56. What is the ratio of the Rent(as % of GDP) of Russian Federation in 1998 to that in 1999?
Offer a very short reply. 0.78. What is the ratio of the Rent(as % of GDP) of Vietnam in 1998 to that in 1999?
Keep it short and to the point. 0.94. What is the ratio of the Rent(as % of GDP) in Sub-Saharan Africa (developing only) in 1998 to that in 2000?
Keep it short and to the point. 0.93. What is the ratio of the Rent(as % of GDP) of Namibia in 1998 to that in 2000?
Provide a short and direct response. 0.53. What is the ratio of the Rent(as % of GDP) of Russian Federation in 1998 to that in 2000?
Keep it short and to the point. 0.18. What is the ratio of the Rent(as % of GDP) of Vietnam in 1998 to that in 2000?
Make the answer very short. 0.99. What is the ratio of the Rent(as % of GDP) in Sub-Saharan Africa (developing only) in 1998 to that in 2001?
Offer a terse response. 1. What is the ratio of the Rent(as % of GDP) of Namibia in 1998 to that in 2001?
Keep it short and to the point. 0.71. What is the ratio of the Rent(as % of GDP) of Russian Federation in 1998 to that in 2001?
Give a very brief answer. 0.67. What is the ratio of the Rent(as % of GDP) in Vietnam in 1998 to that in 2001?
Your answer should be very brief. 1.51. What is the ratio of the Rent(as % of GDP) in Sub-Saharan Africa (developing only) in 1998 to that in 2002?
Give a very brief answer. 0.71. What is the ratio of the Rent(as % of GDP) of Namibia in 1998 to that in 2002?
Offer a terse response. 0.34. What is the ratio of the Rent(as % of GDP) in Russian Federation in 1998 to that in 2002?
Give a very brief answer. 0.32. What is the ratio of the Rent(as % of GDP) of Vietnam in 1998 to that in 2002?
Make the answer very short. 1.13. What is the ratio of the Rent(as % of GDP) in Sub-Saharan Africa (developing only) in 1998 to that in 2003?
Offer a very short reply. 0.53. What is the ratio of the Rent(as % of GDP) of Namibia in 1998 to that in 2003?
Ensure brevity in your answer.  0.29. What is the ratio of the Rent(as % of GDP) in Russian Federation in 1998 to that in 2003?
Your answer should be compact. 0.18. What is the ratio of the Rent(as % of GDP) of Vietnam in 1998 to that in 2003?
Your response must be concise. 0.8. What is the ratio of the Rent(as % of GDP) of Sub-Saharan Africa (developing only) in 1999 to that in 2000?
Give a very brief answer. 0.7. What is the ratio of the Rent(as % of GDP) in Namibia in 1999 to that in 2000?
Give a very brief answer. 0.34. What is the ratio of the Rent(as % of GDP) in Russian Federation in 1999 to that in 2000?
Your answer should be compact. 0.23. What is the ratio of the Rent(as % of GDP) of Vietnam in 1999 to that in 2000?
Your answer should be compact. 1.04. What is the ratio of the Rent(as % of GDP) in Sub-Saharan Africa (developing only) in 1999 to that in 2001?
Keep it short and to the point. 0.76. What is the ratio of the Rent(as % of GDP) in Namibia in 1999 to that in 2001?
Provide a succinct answer. 0.46. What is the ratio of the Rent(as % of GDP) in Russian Federation in 1999 to that in 2001?
Offer a terse response. 0.86. What is the ratio of the Rent(as % of GDP) in Vietnam in 1999 to that in 2001?
Your answer should be compact. 1.6. What is the ratio of the Rent(as % of GDP) of Sub-Saharan Africa (developing only) in 1999 to that in 2002?
Provide a short and direct response. 0.53. What is the ratio of the Rent(as % of GDP) of Namibia in 1999 to that in 2002?
Keep it short and to the point. 0.22. What is the ratio of the Rent(as % of GDP) in Russian Federation in 1999 to that in 2002?
Make the answer very short. 0.42. What is the ratio of the Rent(as % of GDP) in Vietnam in 1999 to that in 2002?
Give a very brief answer. 1.19. What is the ratio of the Rent(as % of GDP) of Sub-Saharan Africa (developing only) in 1999 to that in 2003?
Provide a short and direct response. 0.4. What is the ratio of the Rent(as % of GDP) of Namibia in 1999 to that in 2003?
Provide a short and direct response. 0.19. What is the ratio of the Rent(as % of GDP) in Russian Federation in 1999 to that in 2003?
Keep it short and to the point. 0.23. What is the ratio of the Rent(as % of GDP) in Vietnam in 1999 to that in 2003?
Offer a terse response. 0.85. What is the ratio of the Rent(as % of GDP) of Sub-Saharan Africa (developing only) in 2000 to that in 2001?
Make the answer very short. 1.07. What is the ratio of the Rent(as % of GDP) in Namibia in 2000 to that in 2001?
Your answer should be compact. 1.35. What is the ratio of the Rent(as % of GDP) of Russian Federation in 2000 to that in 2001?
Keep it short and to the point. 3.79. What is the ratio of the Rent(as % of GDP) of Vietnam in 2000 to that in 2001?
Ensure brevity in your answer.  1.54. What is the ratio of the Rent(as % of GDP) in Sub-Saharan Africa (developing only) in 2000 to that in 2002?
Provide a succinct answer. 0.76. What is the ratio of the Rent(as % of GDP) in Namibia in 2000 to that in 2002?
Keep it short and to the point. 0.65. What is the ratio of the Rent(as % of GDP) of Russian Federation in 2000 to that in 2002?
Offer a very short reply. 1.83. What is the ratio of the Rent(as % of GDP) of Vietnam in 2000 to that in 2002?
Offer a terse response. 1.14. What is the ratio of the Rent(as % of GDP) of Sub-Saharan Africa (developing only) in 2000 to that in 2003?
Your answer should be compact. 0.57. What is the ratio of the Rent(as % of GDP) of Namibia in 2000 to that in 2003?
Give a very brief answer. 0.55. What is the ratio of the Rent(as % of GDP) of Russian Federation in 2000 to that in 2003?
Provide a succinct answer. 1.01. What is the ratio of the Rent(as % of GDP) in Vietnam in 2000 to that in 2003?
Provide a short and direct response. 0.81. What is the ratio of the Rent(as % of GDP) in Sub-Saharan Africa (developing only) in 2001 to that in 2002?
Provide a succinct answer. 0.71. What is the ratio of the Rent(as % of GDP) in Namibia in 2001 to that in 2002?
Provide a short and direct response. 0.48. What is the ratio of the Rent(as % of GDP) in Russian Federation in 2001 to that in 2002?
Make the answer very short. 0.48. What is the ratio of the Rent(as % of GDP) in Vietnam in 2001 to that in 2002?
Your answer should be very brief. 0.74. What is the ratio of the Rent(as % of GDP) of Sub-Saharan Africa (developing only) in 2001 to that in 2003?
Provide a succinct answer. 0.53. What is the ratio of the Rent(as % of GDP) in Namibia in 2001 to that in 2003?
Provide a succinct answer. 0.41. What is the ratio of the Rent(as % of GDP) of Russian Federation in 2001 to that in 2003?
Provide a short and direct response. 0.27. What is the ratio of the Rent(as % of GDP) in Vietnam in 2001 to that in 2003?
Keep it short and to the point. 0.53. What is the ratio of the Rent(as % of GDP) in Sub-Saharan Africa (developing only) in 2002 to that in 2003?
Provide a succinct answer. 0.75. What is the ratio of the Rent(as % of GDP) in Namibia in 2002 to that in 2003?
Your answer should be compact. 0.85. What is the ratio of the Rent(as % of GDP) of Russian Federation in 2002 to that in 2003?
Ensure brevity in your answer.  0.55. What is the ratio of the Rent(as % of GDP) in Vietnam in 2002 to that in 2003?
Keep it short and to the point. 0.71. What is the difference between the highest and the second highest Rent(as % of GDP) of Sub-Saharan Africa (developing only)?
Make the answer very short. 0.12. What is the difference between the highest and the second highest Rent(as % of GDP) of Namibia?
Make the answer very short. 0.34. What is the difference between the highest and the second highest Rent(as % of GDP) of Russian Federation?
Your answer should be very brief. 0.01. What is the difference between the highest and the second highest Rent(as % of GDP) in Vietnam?
Ensure brevity in your answer.  0.01. What is the difference between the highest and the lowest Rent(as % of GDP) in Sub-Saharan Africa (developing only)?
Provide a succinct answer. 0.33. What is the difference between the highest and the lowest Rent(as % of GDP) in Namibia?
Your response must be concise. 0.62. What is the difference between the highest and the lowest Rent(as % of GDP) of Russian Federation?
Your response must be concise. 0.4. What is the difference between the highest and the lowest Rent(as % of GDP) in Vietnam?
Ensure brevity in your answer.  0.03. 